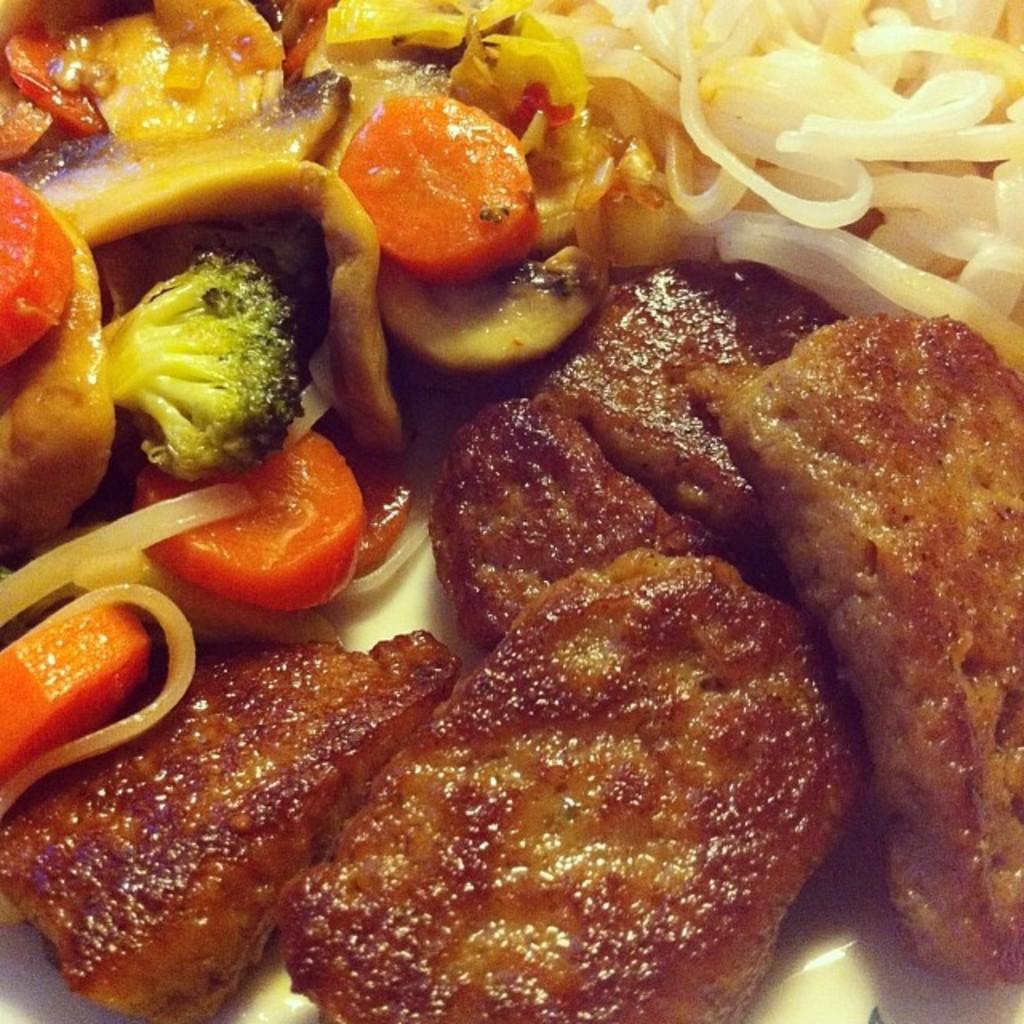What is present on the plate in the image? There is food on a plate in the image. What type of coal is being used to stitch the things in the image? There is no coal or stitching present in the image; it only features food on a plate. 